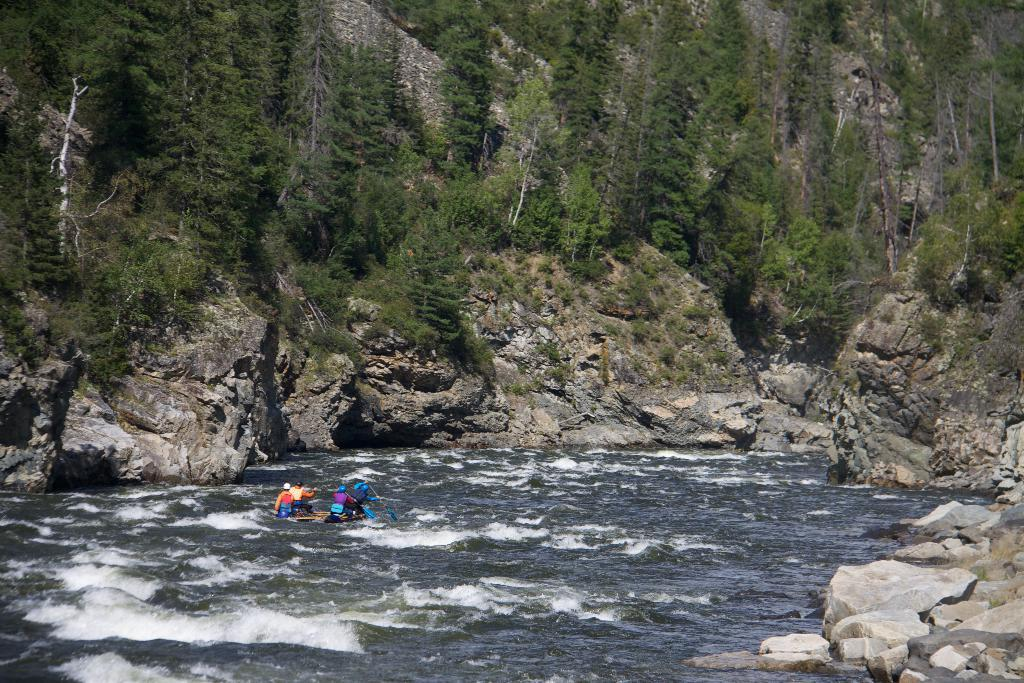How many people are in the boat in the image? There are four persons boating in the water. What type of natural features can be seen in the image? Stones, rocks, mountains, and trees are visible in the image. What time of day was the image likely taken? The image was likely taken during the day, as there is sufficient light to see the details. What type of mark does the doctor leave on the oatmeal in the image? There is no doctor or oatmeal present in the image, so this question cannot be answered. 